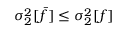Convert formula to latex. <formula><loc_0><loc_0><loc_500><loc_500>\sigma _ { 2 } ^ { 2 } [ \bar { f } ] \leq \sigma _ { 2 } ^ { 2 } [ f ]</formula> 